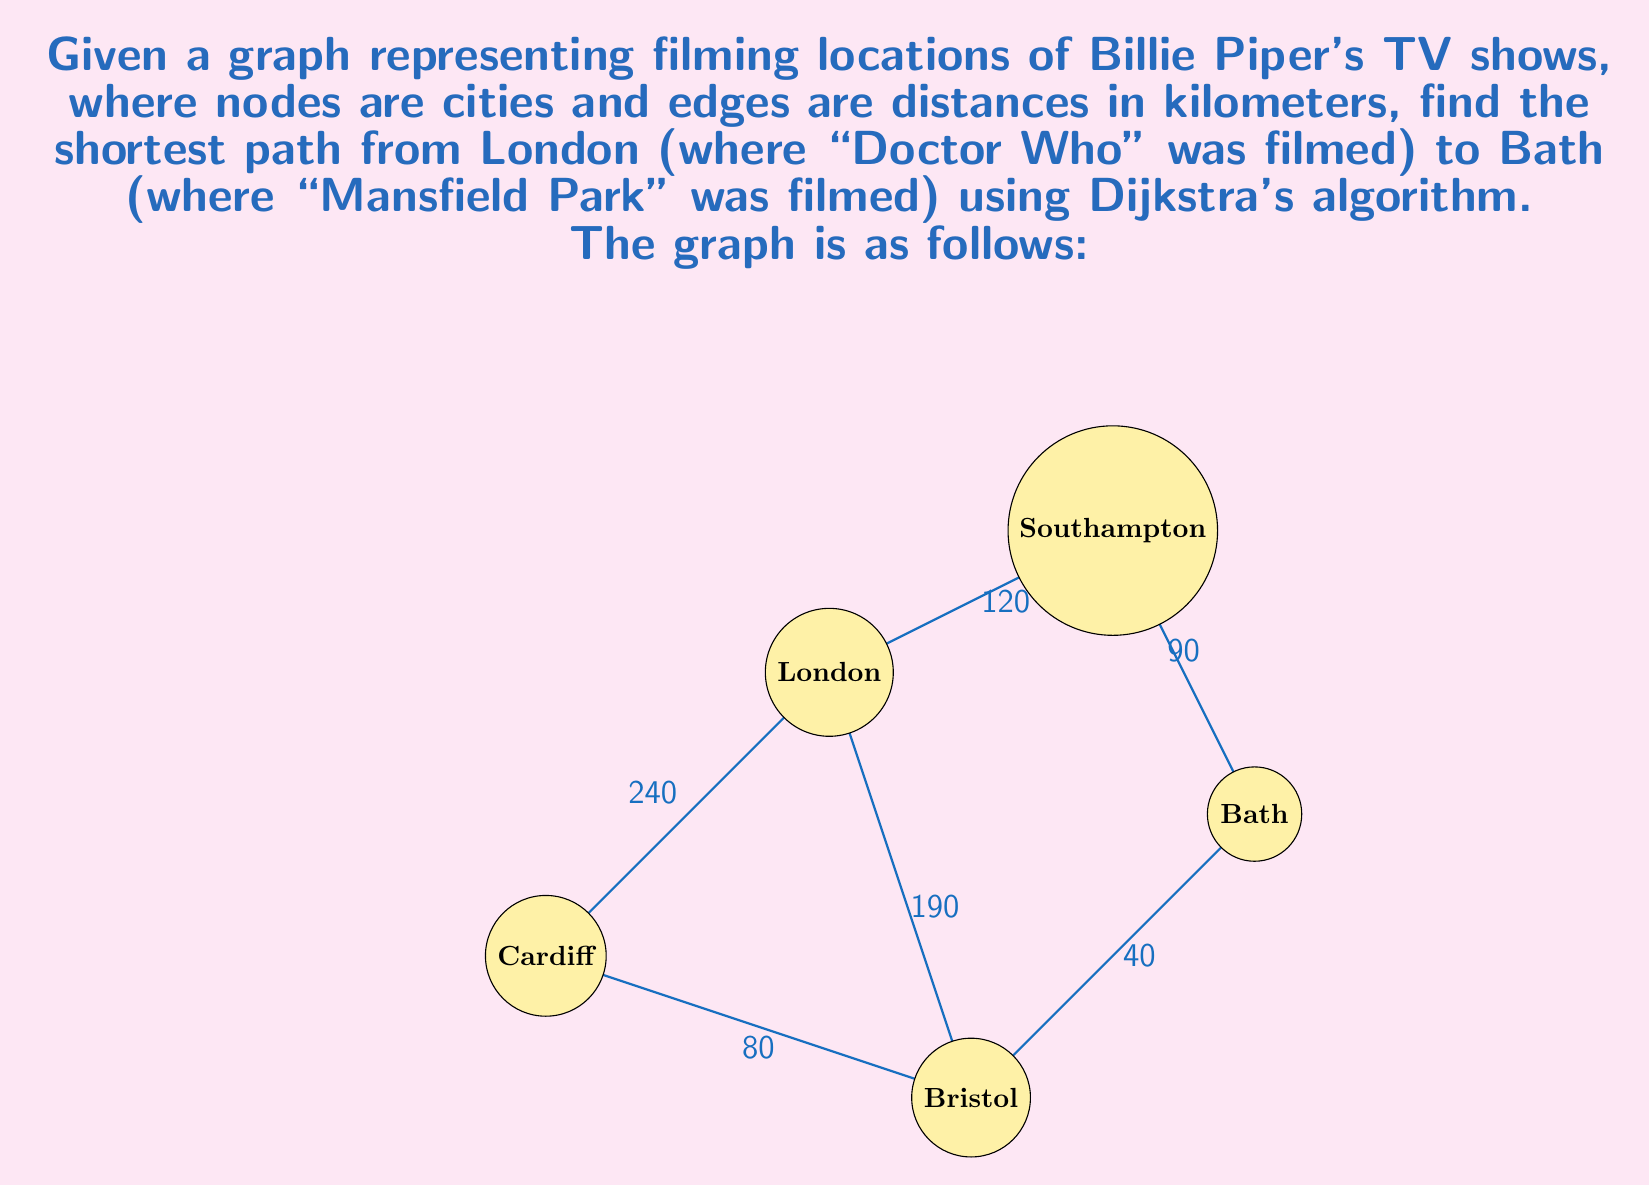Teach me how to tackle this problem. To solve this problem, we'll use Dijkstra's algorithm to find the shortest path from London to Bath. Let's follow the steps:

1) Initialize:
   - Set distance to London as 0
   - Set distances to all other nodes as infinity
   - Set all nodes as unvisited

2) For the current node (starting with London), consider all its unvisited neighbors and calculate their tentative distances.
   - London to Cardiff: 240 km
   - London to Bristol: 190 km
   - London to Southampton: 120 km

3) Update the neighbor's distance if the calculated distance is less than the previously recorded distance.

4) Mark the current node as visited and remove it from the unvisited set.

5) If the destination node (Bath) has been marked visited, we're done. Otherwise, select the unvisited node with the smallest tentative distance and repeat from step 2.

Let's execute the algorithm:

Iteration 1 (London):
- Mark London as visited
- Update distances: Cardiff (240), Bristol (190), Southampton (120)
- Choose Southampton (120) as next node

Iteration 2 (Southampton):
- Mark Southampton as visited
- Update distance to Bath: 120 + 90 = 210
- Choose Bristol (190) as next node

Iteration 3 (Bristol):
- Mark Bristol as visited
- Update distance to Bath: min(210, 190 + 40) = 230
- Choose Bath (230) as next node

The algorithm terminates as we've reached Bath.

The shortest path is London -> Bristol -> Bath, with a total distance of 230 km.
Answer: The shortest path from London to Bath is London -> Bristol -> Bath, with a total distance of 230 km. 